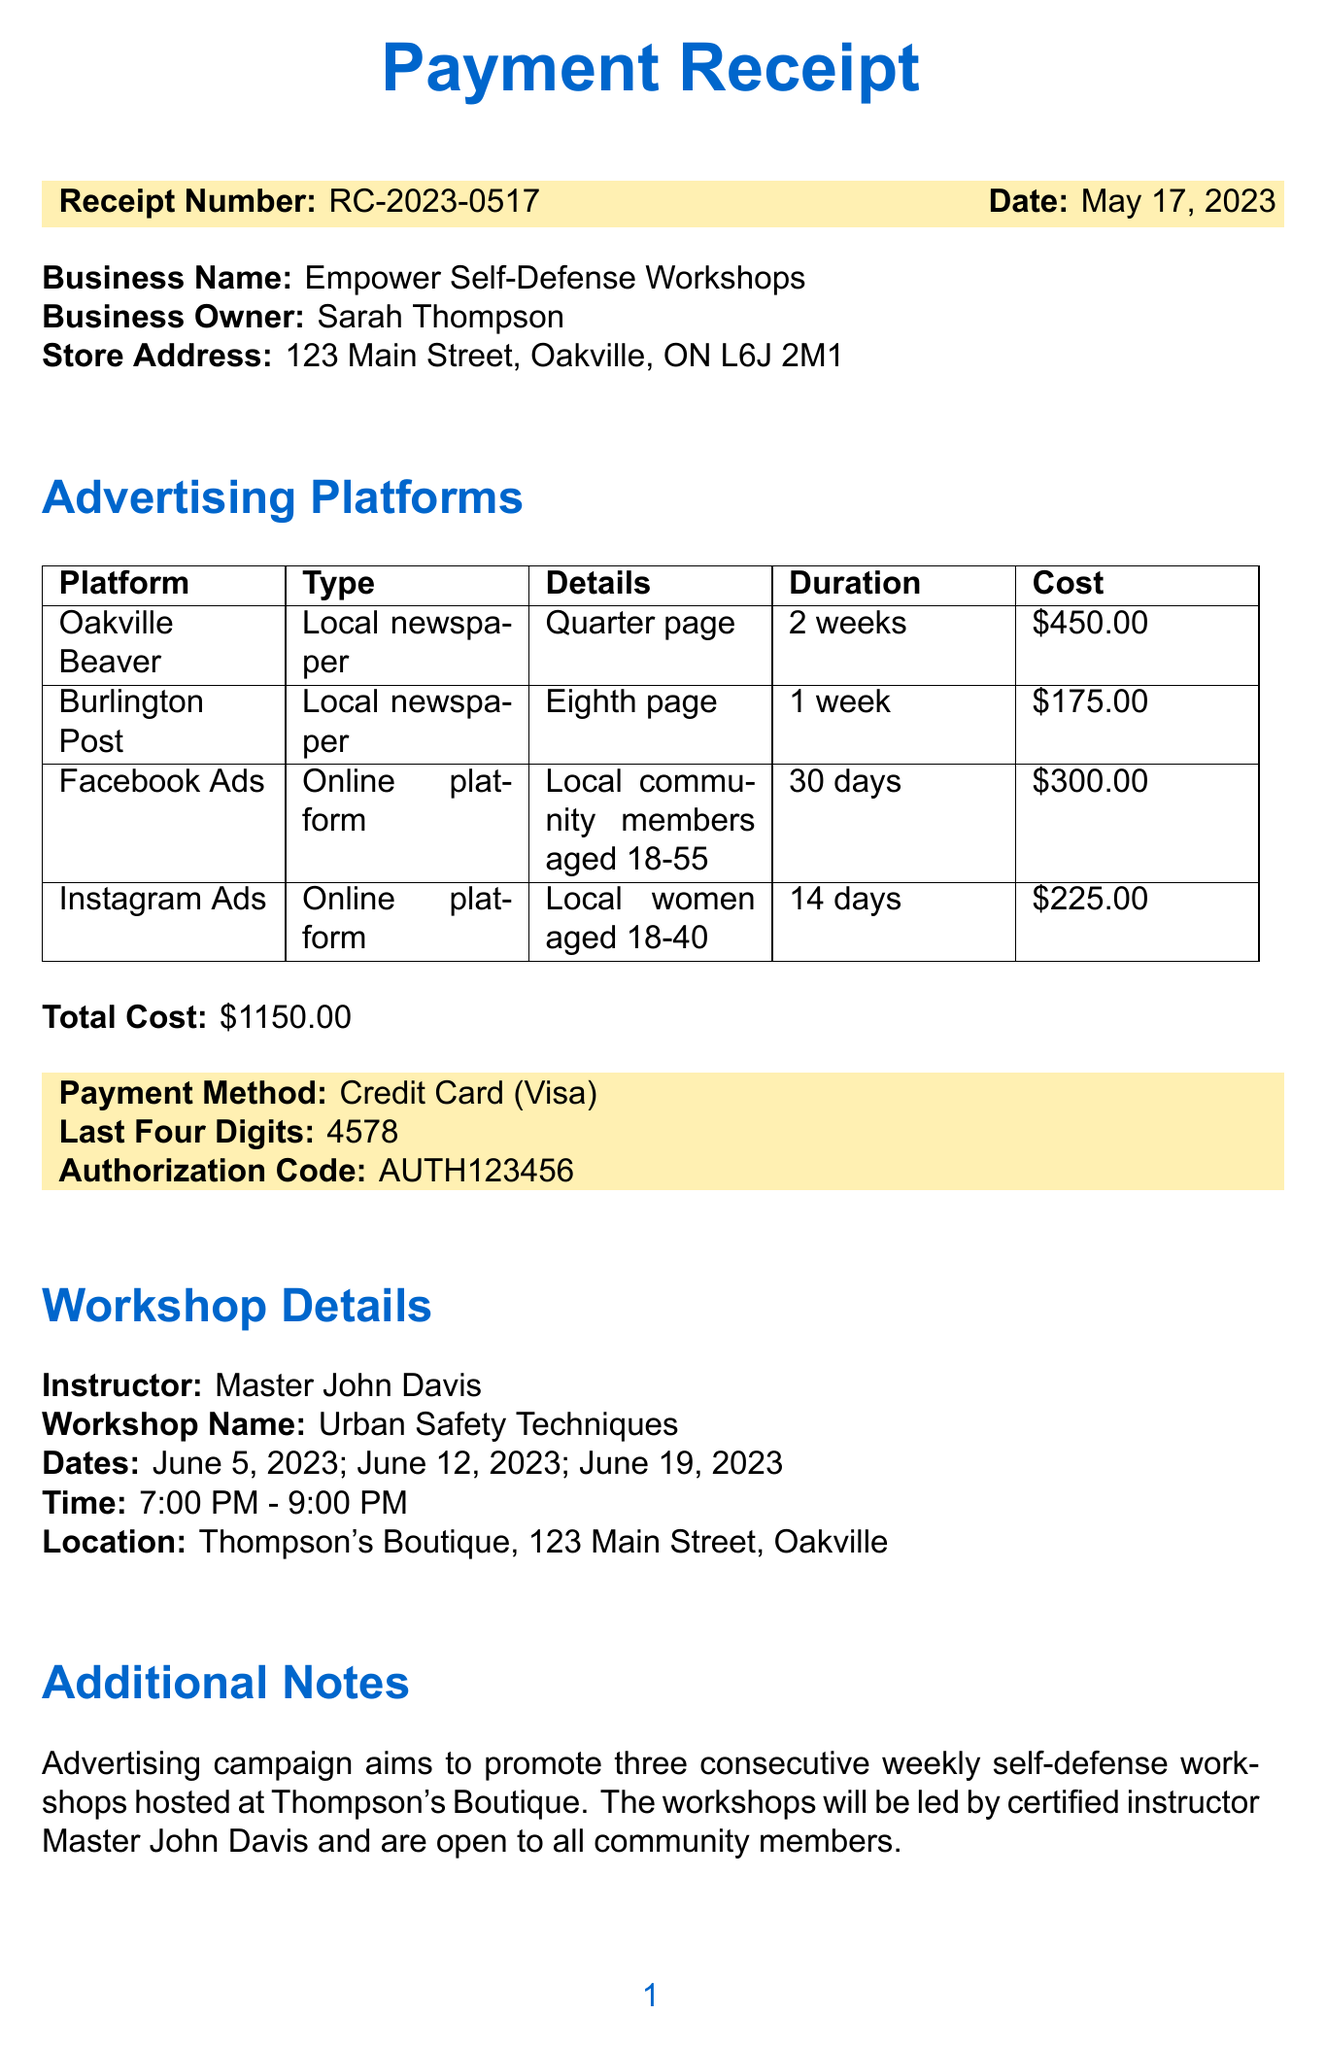What is the receipt number? The receipt number can be found at the beginning of the document, labeled as "Receipt Number."
Answer: RC-2023-0517 What is the date of the receipt? The date is listed next to the receipt number in the document.
Answer: May 17, 2023 Who is the business owner? The business owner's name is mentioned under the business details section.
Answer: Sarah Thompson What is the total cost of the advertising? The total cost is indicated in the document under the total cost section.
Answer: $1150.00 How many workshops are being promoted? The document outlines that three workshops are included in the advertising campaign.
Answer: Three What is the duration of the Facebook Ads campaign? The duration of the Facebook Ads is detailed in the advertising platforms section.
Answer: 30 days What method of payment was used? The payment method is specified towards the end of the receipt.
Answer: Credit Card What is the location of the workshops? The workshop location is provided in the workshop details section of the document.
Answer: Thompson's Boutique, 123 Main Street, Oakville Who will be leading the workshops? The instructor's name is mentioned in the workshop details section of the document.
Answer: Master John Davis 